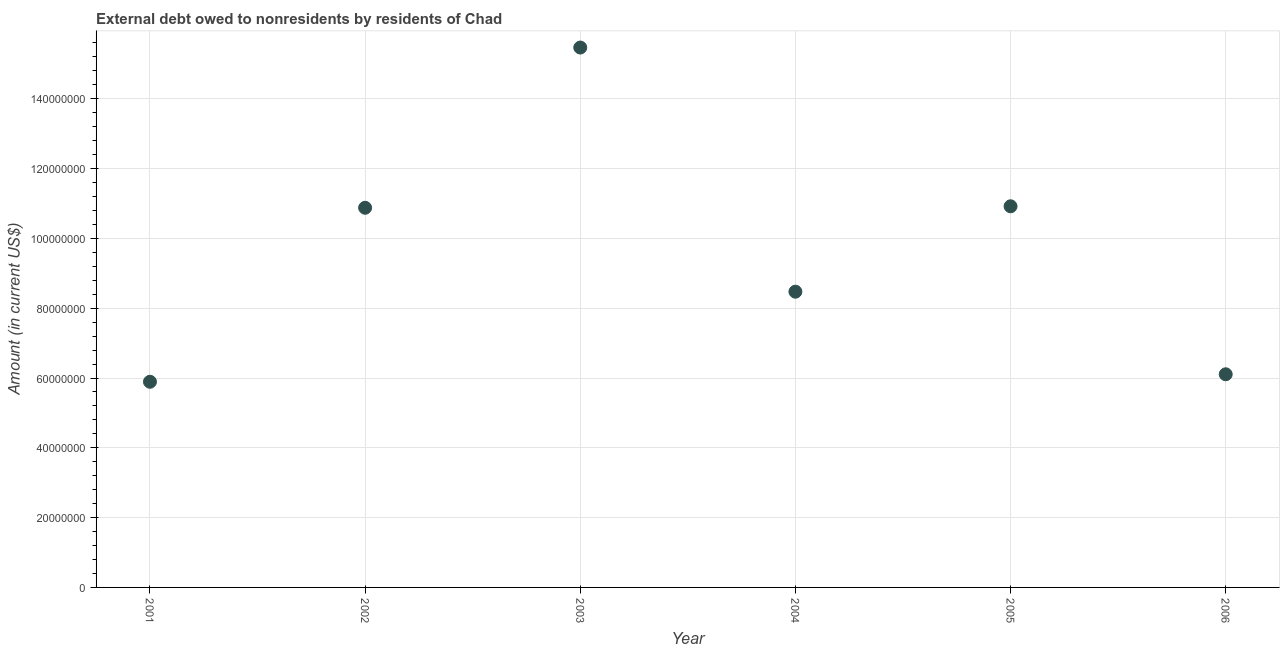What is the debt in 2002?
Keep it short and to the point. 1.09e+08. Across all years, what is the maximum debt?
Your response must be concise. 1.55e+08. Across all years, what is the minimum debt?
Offer a terse response. 5.89e+07. In which year was the debt maximum?
Ensure brevity in your answer.  2003. What is the sum of the debt?
Provide a succinct answer. 5.77e+08. What is the difference between the debt in 2004 and 2006?
Ensure brevity in your answer.  2.37e+07. What is the average debt per year?
Make the answer very short. 9.62e+07. What is the median debt?
Offer a terse response. 9.68e+07. What is the ratio of the debt in 2001 to that in 2002?
Make the answer very short. 0.54. What is the difference between the highest and the second highest debt?
Your answer should be very brief. 4.55e+07. What is the difference between the highest and the lowest debt?
Your answer should be very brief. 9.58e+07. In how many years, is the debt greater than the average debt taken over all years?
Make the answer very short. 3. How many years are there in the graph?
Your answer should be compact. 6. Are the values on the major ticks of Y-axis written in scientific E-notation?
Give a very brief answer. No. What is the title of the graph?
Your response must be concise. External debt owed to nonresidents by residents of Chad. What is the label or title of the X-axis?
Your answer should be compact. Year. What is the label or title of the Y-axis?
Provide a short and direct response. Amount (in current US$). What is the Amount (in current US$) in 2001?
Give a very brief answer. 5.89e+07. What is the Amount (in current US$) in 2002?
Ensure brevity in your answer.  1.09e+08. What is the Amount (in current US$) in 2003?
Your answer should be very brief. 1.55e+08. What is the Amount (in current US$) in 2004?
Your response must be concise. 8.47e+07. What is the Amount (in current US$) in 2005?
Your answer should be very brief. 1.09e+08. What is the Amount (in current US$) in 2006?
Make the answer very short. 6.11e+07. What is the difference between the Amount (in current US$) in 2001 and 2002?
Keep it short and to the point. -4.99e+07. What is the difference between the Amount (in current US$) in 2001 and 2003?
Your response must be concise. -9.58e+07. What is the difference between the Amount (in current US$) in 2001 and 2004?
Provide a short and direct response. -2.58e+07. What is the difference between the Amount (in current US$) in 2001 and 2005?
Provide a succinct answer. -5.03e+07. What is the difference between the Amount (in current US$) in 2001 and 2006?
Give a very brief answer. -2.14e+06. What is the difference between the Amount (in current US$) in 2002 and 2003?
Provide a short and direct response. -4.59e+07. What is the difference between the Amount (in current US$) in 2002 and 2004?
Your answer should be very brief. 2.40e+07. What is the difference between the Amount (in current US$) in 2002 and 2005?
Keep it short and to the point. -4.26e+05. What is the difference between the Amount (in current US$) in 2002 and 2006?
Offer a very short reply. 4.77e+07. What is the difference between the Amount (in current US$) in 2003 and 2004?
Make the answer very short. 7.00e+07. What is the difference between the Amount (in current US$) in 2003 and 2005?
Your answer should be very brief. 4.55e+07. What is the difference between the Amount (in current US$) in 2003 and 2006?
Your answer should be compact. 9.36e+07. What is the difference between the Amount (in current US$) in 2004 and 2005?
Offer a terse response. -2.45e+07. What is the difference between the Amount (in current US$) in 2004 and 2006?
Offer a terse response. 2.37e+07. What is the difference between the Amount (in current US$) in 2005 and 2006?
Give a very brief answer. 4.81e+07. What is the ratio of the Amount (in current US$) in 2001 to that in 2002?
Provide a succinct answer. 0.54. What is the ratio of the Amount (in current US$) in 2001 to that in 2003?
Provide a short and direct response. 0.38. What is the ratio of the Amount (in current US$) in 2001 to that in 2004?
Give a very brief answer. 0.69. What is the ratio of the Amount (in current US$) in 2001 to that in 2005?
Ensure brevity in your answer.  0.54. What is the ratio of the Amount (in current US$) in 2002 to that in 2003?
Provide a short and direct response. 0.7. What is the ratio of the Amount (in current US$) in 2002 to that in 2004?
Provide a succinct answer. 1.28. What is the ratio of the Amount (in current US$) in 2002 to that in 2006?
Give a very brief answer. 1.78. What is the ratio of the Amount (in current US$) in 2003 to that in 2004?
Provide a short and direct response. 1.83. What is the ratio of the Amount (in current US$) in 2003 to that in 2005?
Offer a terse response. 1.42. What is the ratio of the Amount (in current US$) in 2003 to that in 2006?
Give a very brief answer. 2.53. What is the ratio of the Amount (in current US$) in 2004 to that in 2005?
Keep it short and to the point. 0.78. What is the ratio of the Amount (in current US$) in 2004 to that in 2006?
Your response must be concise. 1.39. What is the ratio of the Amount (in current US$) in 2005 to that in 2006?
Offer a terse response. 1.79. 